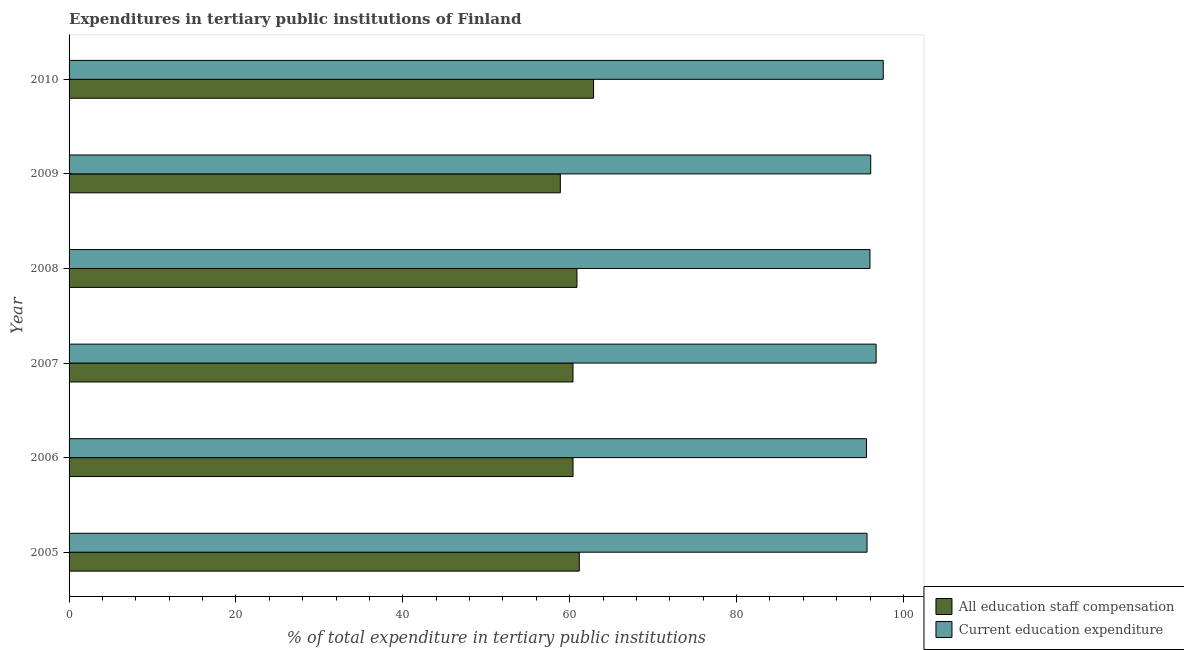How many groups of bars are there?
Give a very brief answer. 6. Are the number of bars per tick equal to the number of legend labels?
Offer a very short reply. Yes. Are the number of bars on each tick of the Y-axis equal?
Offer a very short reply. Yes. What is the label of the 3rd group of bars from the top?
Provide a succinct answer. 2008. What is the expenditure in staff compensation in 2007?
Your answer should be compact. 60.39. Across all years, what is the maximum expenditure in education?
Provide a short and direct response. 97.58. Across all years, what is the minimum expenditure in staff compensation?
Your answer should be very brief. 58.88. In which year was the expenditure in staff compensation maximum?
Provide a succinct answer. 2010. In which year was the expenditure in staff compensation minimum?
Make the answer very short. 2009. What is the total expenditure in staff compensation in the graph?
Provide a succinct answer. 364.55. What is the difference between the expenditure in education in 2008 and that in 2009?
Ensure brevity in your answer.  -0.09. What is the difference between the expenditure in education in 2005 and the expenditure in staff compensation in 2006?
Your answer should be compact. 35.24. What is the average expenditure in education per year?
Offer a terse response. 96.26. In the year 2005, what is the difference between the expenditure in staff compensation and expenditure in education?
Provide a succinct answer. -34.48. In how many years, is the expenditure in education greater than 28 %?
Ensure brevity in your answer.  6. Is the expenditure in staff compensation in 2005 less than that in 2009?
Ensure brevity in your answer.  No. Is the difference between the expenditure in education in 2005 and 2008 greater than the difference between the expenditure in staff compensation in 2005 and 2008?
Your answer should be very brief. No. What is the difference between the highest and the second highest expenditure in education?
Ensure brevity in your answer.  0.85. What is the difference between the highest and the lowest expenditure in staff compensation?
Provide a succinct answer. 3.98. What does the 1st bar from the top in 2006 represents?
Offer a very short reply. Current education expenditure. What does the 1st bar from the bottom in 2005 represents?
Keep it short and to the point. All education staff compensation. Are all the bars in the graph horizontal?
Your answer should be compact. Yes. How many years are there in the graph?
Offer a very short reply. 6. Are the values on the major ticks of X-axis written in scientific E-notation?
Provide a succinct answer. No. Does the graph contain grids?
Your answer should be compact. No. How are the legend labels stacked?
Keep it short and to the point. Vertical. What is the title of the graph?
Offer a very short reply. Expenditures in tertiary public institutions of Finland. What is the label or title of the X-axis?
Give a very brief answer. % of total expenditure in tertiary public institutions. What is the label or title of the Y-axis?
Ensure brevity in your answer.  Year. What is the % of total expenditure in tertiary public institutions of All education staff compensation in 2005?
Offer a terse response. 61.15. What is the % of total expenditure in tertiary public institutions in Current education expenditure in 2005?
Give a very brief answer. 95.64. What is the % of total expenditure in tertiary public institutions of All education staff compensation in 2006?
Give a very brief answer. 60.4. What is the % of total expenditure in tertiary public institutions of Current education expenditure in 2006?
Provide a succinct answer. 95.57. What is the % of total expenditure in tertiary public institutions of All education staff compensation in 2007?
Give a very brief answer. 60.39. What is the % of total expenditure in tertiary public institutions of Current education expenditure in 2007?
Make the answer very short. 96.72. What is the % of total expenditure in tertiary public institutions in All education staff compensation in 2008?
Your answer should be compact. 60.87. What is the % of total expenditure in tertiary public institutions of Current education expenditure in 2008?
Offer a terse response. 95.99. What is the % of total expenditure in tertiary public institutions in All education staff compensation in 2009?
Make the answer very short. 58.88. What is the % of total expenditure in tertiary public institutions of Current education expenditure in 2009?
Give a very brief answer. 96.07. What is the % of total expenditure in tertiary public institutions of All education staff compensation in 2010?
Your answer should be very brief. 62.86. What is the % of total expenditure in tertiary public institutions of Current education expenditure in 2010?
Your response must be concise. 97.58. Across all years, what is the maximum % of total expenditure in tertiary public institutions in All education staff compensation?
Provide a succinct answer. 62.86. Across all years, what is the maximum % of total expenditure in tertiary public institutions in Current education expenditure?
Make the answer very short. 97.58. Across all years, what is the minimum % of total expenditure in tertiary public institutions of All education staff compensation?
Your answer should be compact. 58.88. Across all years, what is the minimum % of total expenditure in tertiary public institutions of Current education expenditure?
Your answer should be very brief. 95.57. What is the total % of total expenditure in tertiary public institutions in All education staff compensation in the graph?
Your response must be concise. 364.55. What is the total % of total expenditure in tertiary public institutions of Current education expenditure in the graph?
Keep it short and to the point. 577.57. What is the difference between the % of total expenditure in tertiary public institutions in All education staff compensation in 2005 and that in 2006?
Make the answer very short. 0.75. What is the difference between the % of total expenditure in tertiary public institutions of Current education expenditure in 2005 and that in 2006?
Your answer should be very brief. 0.06. What is the difference between the % of total expenditure in tertiary public institutions in All education staff compensation in 2005 and that in 2007?
Your response must be concise. 0.76. What is the difference between the % of total expenditure in tertiary public institutions in Current education expenditure in 2005 and that in 2007?
Your answer should be compact. -1.09. What is the difference between the % of total expenditure in tertiary public institutions in All education staff compensation in 2005 and that in 2008?
Provide a short and direct response. 0.28. What is the difference between the % of total expenditure in tertiary public institutions of Current education expenditure in 2005 and that in 2008?
Offer a very short reply. -0.35. What is the difference between the % of total expenditure in tertiary public institutions in All education staff compensation in 2005 and that in 2009?
Provide a succinct answer. 2.27. What is the difference between the % of total expenditure in tertiary public institutions in Current education expenditure in 2005 and that in 2009?
Provide a succinct answer. -0.44. What is the difference between the % of total expenditure in tertiary public institutions in All education staff compensation in 2005 and that in 2010?
Your answer should be compact. -1.71. What is the difference between the % of total expenditure in tertiary public institutions in Current education expenditure in 2005 and that in 2010?
Keep it short and to the point. -1.94. What is the difference between the % of total expenditure in tertiary public institutions in All education staff compensation in 2006 and that in 2007?
Your response must be concise. 0. What is the difference between the % of total expenditure in tertiary public institutions in Current education expenditure in 2006 and that in 2007?
Your answer should be very brief. -1.15. What is the difference between the % of total expenditure in tertiary public institutions in All education staff compensation in 2006 and that in 2008?
Provide a short and direct response. -0.47. What is the difference between the % of total expenditure in tertiary public institutions in Current education expenditure in 2006 and that in 2008?
Make the answer very short. -0.41. What is the difference between the % of total expenditure in tertiary public institutions of All education staff compensation in 2006 and that in 2009?
Offer a terse response. 1.52. What is the difference between the % of total expenditure in tertiary public institutions in Current education expenditure in 2006 and that in 2009?
Provide a short and direct response. -0.5. What is the difference between the % of total expenditure in tertiary public institutions in All education staff compensation in 2006 and that in 2010?
Your answer should be very brief. -2.46. What is the difference between the % of total expenditure in tertiary public institutions in Current education expenditure in 2006 and that in 2010?
Your answer should be very brief. -2. What is the difference between the % of total expenditure in tertiary public institutions in All education staff compensation in 2007 and that in 2008?
Ensure brevity in your answer.  -0.47. What is the difference between the % of total expenditure in tertiary public institutions of Current education expenditure in 2007 and that in 2008?
Your answer should be compact. 0.74. What is the difference between the % of total expenditure in tertiary public institutions in All education staff compensation in 2007 and that in 2009?
Provide a succinct answer. 1.52. What is the difference between the % of total expenditure in tertiary public institutions of Current education expenditure in 2007 and that in 2009?
Offer a terse response. 0.65. What is the difference between the % of total expenditure in tertiary public institutions in All education staff compensation in 2007 and that in 2010?
Your response must be concise. -2.47. What is the difference between the % of total expenditure in tertiary public institutions in Current education expenditure in 2007 and that in 2010?
Ensure brevity in your answer.  -0.85. What is the difference between the % of total expenditure in tertiary public institutions in All education staff compensation in 2008 and that in 2009?
Provide a short and direct response. 1.99. What is the difference between the % of total expenditure in tertiary public institutions in Current education expenditure in 2008 and that in 2009?
Make the answer very short. -0.09. What is the difference between the % of total expenditure in tertiary public institutions in All education staff compensation in 2008 and that in 2010?
Your answer should be very brief. -1.99. What is the difference between the % of total expenditure in tertiary public institutions in Current education expenditure in 2008 and that in 2010?
Offer a very short reply. -1.59. What is the difference between the % of total expenditure in tertiary public institutions in All education staff compensation in 2009 and that in 2010?
Your response must be concise. -3.98. What is the difference between the % of total expenditure in tertiary public institutions in Current education expenditure in 2009 and that in 2010?
Offer a very short reply. -1.5. What is the difference between the % of total expenditure in tertiary public institutions of All education staff compensation in 2005 and the % of total expenditure in tertiary public institutions of Current education expenditure in 2006?
Offer a terse response. -34.42. What is the difference between the % of total expenditure in tertiary public institutions of All education staff compensation in 2005 and the % of total expenditure in tertiary public institutions of Current education expenditure in 2007?
Provide a succinct answer. -35.57. What is the difference between the % of total expenditure in tertiary public institutions of All education staff compensation in 2005 and the % of total expenditure in tertiary public institutions of Current education expenditure in 2008?
Keep it short and to the point. -34.84. What is the difference between the % of total expenditure in tertiary public institutions of All education staff compensation in 2005 and the % of total expenditure in tertiary public institutions of Current education expenditure in 2009?
Provide a short and direct response. -34.92. What is the difference between the % of total expenditure in tertiary public institutions of All education staff compensation in 2005 and the % of total expenditure in tertiary public institutions of Current education expenditure in 2010?
Provide a short and direct response. -36.43. What is the difference between the % of total expenditure in tertiary public institutions of All education staff compensation in 2006 and the % of total expenditure in tertiary public institutions of Current education expenditure in 2007?
Provide a short and direct response. -36.32. What is the difference between the % of total expenditure in tertiary public institutions in All education staff compensation in 2006 and the % of total expenditure in tertiary public institutions in Current education expenditure in 2008?
Provide a short and direct response. -35.59. What is the difference between the % of total expenditure in tertiary public institutions in All education staff compensation in 2006 and the % of total expenditure in tertiary public institutions in Current education expenditure in 2009?
Keep it short and to the point. -35.67. What is the difference between the % of total expenditure in tertiary public institutions of All education staff compensation in 2006 and the % of total expenditure in tertiary public institutions of Current education expenditure in 2010?
Your response must be concise. -37.18. What is the difference between the % of total expenditure in tertiary public institutions in All education staff compensation in 2007 and the % of total expenditure in tertiary public institutions in Current education expenditure in 2008?
Offer a very short reply. -35.59. What is the difference between the % of total expenditure in tertiary public institutions in All education staff compensation in 2007 and the % of total expenditure in tertiary public institutions in Current education expenditure in 2009?
Ensure brevity in your answer.  -35.68. What is the difference between the % of total expenditure in tertiary public institutions in All education staff compensation in 2007 and the % of total expenditure in tertiary public institutions in Current education expenditure in 2010?
Provide a short and direct response. -37.18. What is the difference between the % of total expenditure in tertiary public institutions in All education staff compensation in 2008 and the % of total expenditure in tertiary public institutions in Current education expenditure in 2009?
Keep it short and to the point. -35.21. What is the difference between the % of total expenditure in tertiary public institutions of All education staff compensation in 2008 and the % of total expenditure in tertiary public institutions of Current education expenditure in 2010?
Your answer should be compact. -36.71. What is the difference between the % of total expenditure in tertiary public institutions of All education staff compensation in 2009 and the % of total expenditure in tertiary public institutions of Current education expenditure in 2010?
Ensure brevity in your answer.  -38.7. What is the average % of total expenditure in tertiary public institutions in All education staff compensation per year?
Keep it short and to the point. 60.76. What is the average % of total expenditure in tertiary public institutions in Current education expenditure per year?
Give a very brief answer. 96.26. In the year 2005, what is the difference between the % of total expenditure in tertiary public institutions of All education staff compensation and % of total expenditure in tertiary public institutions of Current education expenditure?
Your answer should be compact. -34.49. In the year 2006, what is the difference between the % of total expenditure in tertiary public institutions of All education staff compensation and % of total expenditure in tertiary public institutions of Current education expenditure?
Your answer should be compact. -35.17. In the year 2007, what is the difference between the % of total expenditure in tertiary public institutions in All education staff compensation and % of total expenditure in tertiary public institutions in Current education expenditure?
Give a very brief answer. -36.33. In the year 2008, what is the difference between the % of total expenditure in tertiary public institutions of All education staff compensation and % of total expenditure in tertiary public institutions of Current education expenditure?
Give a very brief answer. -35.12. In the year 2009, what is the difference between the % of total expenditure in tertiary public institutions in All education staff compensation and % of total expenditure in tertiary public institutions in Current education expenditure?
Ensure brevity in your answer.  -37.2. In the year 2010, what is the difference between the % of total expenditure in tertiary public institutions in All education staff compensation and % of total expenditure in tertiary public institutions in Current education expenditure?
Make the answer very short. -34.72. What is the ratio of the % of total expenditure in tertiary public institutions in All education staff compensation in 2005 to that in 2006?
Your response must be concise. 1.01. What is the ratio of the % of total expenditure in tertiary public institutions in All education staff compensation in 2005 to that in 2007?
Your response must be concise. 1.01. What is the ratio of the % of total expenditure in tertiary public institutions of Current education expenditure in 2005 to that in 2007?
Give a very brief answer. 0.99. What is the ratio of the % of total expenditure in tertiary public institutions of All education staff compensation in 2005 to that in 2009?
Keep it short and to the point. 1.04. What is the ratio of the % of total expenditure in tertiary public institutions in All education staff compensation in 2005 to that in 2010?
Provide a succinct answer. 0.97. What is the ratio of the % of total expenditure in tertiary public institutions in Current education expenditure in 2005 to that in 2010?
Offer a very short reply. 0.98. What is the ratio of the % of total expenditure in tertiary public institutions of All education staff compensation in 2006 to that in 2007?
Keep it short and to the point. 1. What is the ratio of the % of total expenditure in tertiary public institutions of Current education expenditure in 2006 to that in 2007?
Provide a succinct answer. 0.99. What is the ratio of the % of total expenditure in tertiary public institutions in All education staff compensation in 2006 to that in 2009?
Offer a terse response. 1.03. What is the ratio of the % of total expenditure in tertiary public institutions in Current education expenditure in 2006 to that in 2009?
Make the answer very short. 0.99. What is the ratio of the % of total expenditure in tertiary public institutions in All education staff compensation in 2006 to that in 2010?
Give a very brief answer. 0.96. What is the ratio of the % of total expenditure in tertiary public institutions in Current education expenditure in 2006 to that in 2010?
Keep it short and to the point. 0.98. What is the ratio of the % of total expenditure in tertiary public institutions in Current education expenditure in 2007 to that in 2008?
Provide a succinct answer. 1.01. What is the ratio of the % of total expenditure in tertiary public institutions in All education staff compensation in 2007 to that in 2009?
Offer a terse response. 1.03. What is the ratio of the % of total expenditure in tertiary public institutions of Current education expenditure in 2007 to that in 2009?
Provide a succinct answer. 1.01. What is the ratio of the % of total expenditure in tertiary public institutions in All education staff compensation in 2007 to that in 2010?
Ensure brevity in your answer.  0.96. What is the ratio of the % of total expenditure in tertiary public institutions in Current education expenditure in 2007 to that in 2010?
Your answer should be very brief. 0.99. What is the ratio of the % of total expenditure in tertiary public institutions in All education staff compensation in 2008 to that in 2009?
Give a very brief answer. 1.03. What is the ratio of the % of total expenditure in tertiary public institutions in Current education expenditure in 2008 to that in 2009?
Your response must be concise. 1. What is the ratio of the % of total expenditure in tertiary public institutions of All education staff compensation in 2008 to that in 2010?
Make the answer very short. 0.97. What is the ratio of the % of total expenditure in tertiary public institutions of Current education expenditure in 2008 to that in 2010?
Your response must be concise. 0.98. What is the ratio of the % of total expenditure in tertiary public institutions of All education staff compensation in 2009 to that in 2010?
Provide a succinct answer. 0.94. What is the ratio of the % of total expenditure in tertiary public institutions in Current education expenditure in 2009 to that in 2010?
Offer a terse response. 0.98. What is the difference between the highest and the second highest % of total expenditure in tertiary public institutions of All education staff compensation?
Offer a very short reply. 1.71. What is the difference between the highest and the second highest % of total expenditure in tertiary public institutions in Current education expenditure?
Your answer should be compact. 0.85. What is the difference between the highest and the lowest % of total expenditure in tertiary public institutions in All education staff compensation?
Give a very brief answer. 3.98. What is the difference between the highest and the lowest % of total expenditure in tertiary public institutions in Current education expenditure?
Your answer should be very brief. 2. 